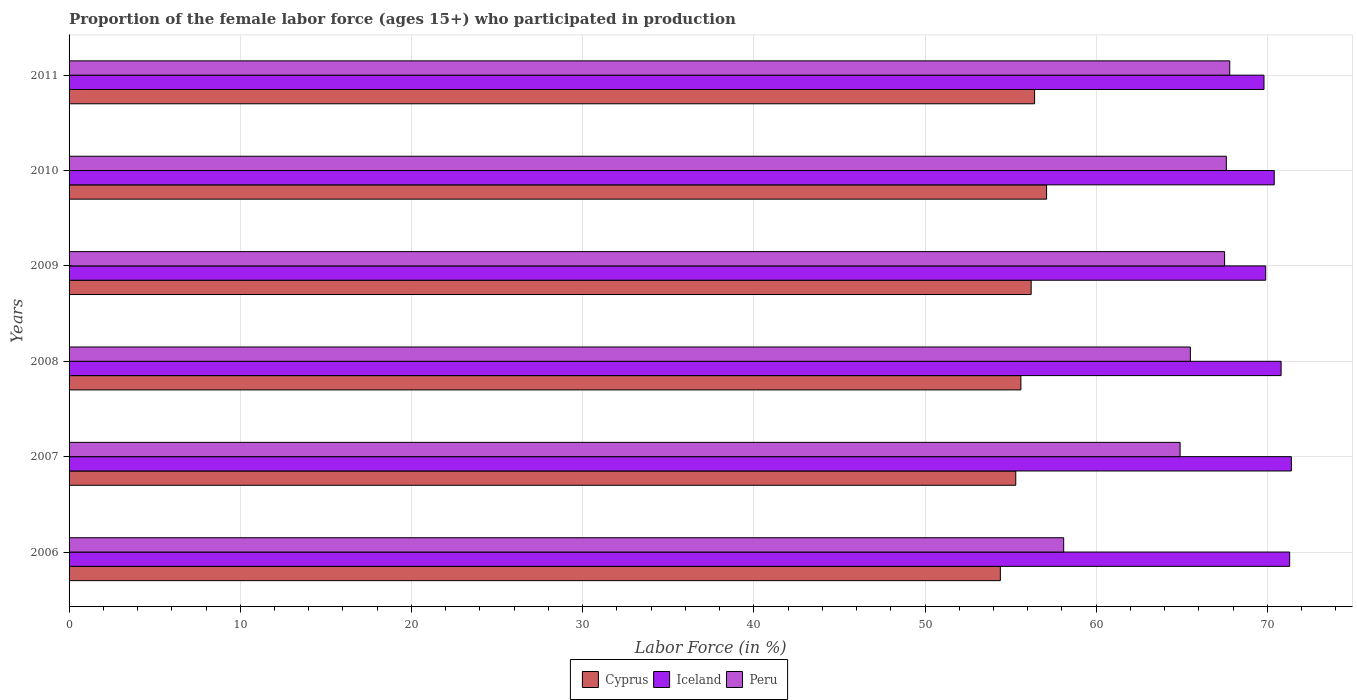How many different coloured bars are there?
Your answer should be compact. 3. How many groups of bars are there?
Provide a succinct answer. 6. Are the number of bars per tick equal to the number of legend labels?
Make the answer very short. Yes. How many bars are there on the 6th tick from the top?
Keep it short and to the point. 3. What is the label of the 4th group of bars from the top?
Provide a short and direct response. 2008. What is the proportion of the female labor force who participated in production in Iceland in 2010?
Offer a terse response. 70.4. Across all years, what is the maximum proportion of the female labor force who participated in production in Iceland?
Keep it short and to the point. 71.4. Across all years, what is the minimum proportion of the female labor force who participated in production in Peru?
Provide a short and direct response. 58.1. In which year was the proportion of the female labor force who participated in production in Iceland maximum?
Offer a terse response. 2007. What is the total proportion of the female labor force who participated in production in Iceland in the graph?
Offer a very short reply. 423.6. What is the difference between the proportion of the female labor force who participated in production in Peru in 2009 and that in 2011?
Offer a terse response. -0.3. What is the difference between the proportion of the female labor force who participated in production in Cyprus in 2010 and the proportion of the female labor force who participated in production in Peru in 2011?
Offer a terse response. -10.7. What is the average proportion of the female labor force who participated in production in Cyprus per year?
Offer a terse response. 55.83. In the year 2006, what is the difference between the proportion of the female labor force who participated in production in Iceland and proportion of the female labor force who participated in production in Peru?
Offer a terse response. 13.2. In how many years, is the proportion of the female labor force who participated in production in Cyprus greater than 48 %?
Your answer should be compact. 6. What is the ratio of the proportion of the female labor force who participated in production in Iceland in 2006 to that in 2009?
Your answer should be very brief. 1.02. What is the difference between the highest and the second highest proportion of the female labor force who participated in production in Cyprus?
Ensure brevity in your answer.  0.7. What is the difference between the highest and the lowest proportion of the female labor force who participated in production in Peru?
Keep it short and to the point. 9.7. In how many years, is the proportion of the female labor force who participated in production in Peru greater than the average proportion of the female labor force who participated in production in Peru taken over all years?
Your answer should be compact. 4. How many bars are there?
Make the answer very short. 18. Are all the bars in the graph horizontal?
Provide a succinct answer. Yes. What is the title of the graph?
Provide a succinct answer. Proportion of the female labor force (ages 15+) who participated in production. Does "Chile" appear as one of the legend labels in the graph?
Offer a terse response. No. What is the Labor Force (in %) in Cyprus in 2006?
Your answer should be compact. 54.4. What is the Labor Force (in %) in Iceland in 2006?
Provide a succinct answer. 71.3. What is the Labor Force (in %) of Peru in 2006?
Keep it short and to the point. 58.1. What is the Labor Force (in %) of Cyprus in 2007?
Offer a very short reply. 55.3. What is the Labor Force (in %) of Iceland in 2007?
Ensure brevity in your answer.  71.4. What is the Labor Force (in %) in Peru in 2007?
Provide a succinct answer. 64.9. What is the Labor Force (in %) of Cyprus in 2008?
Offer a terse response. 55.6. What is the Labor Force (in %) in Iceland in 2008?
Provide a succinct answer. 70.8. What is the Labor Force (in %) of Peru in 2008?
Provide a succinct answer. 65.5. What is the Labor Force (in %) of Cyprus in 2009?
Your response must be concise. 56.2. What is the Labor Force (in %) of Iceland in 2009?
Provide a short and direct response. 69.9. What is the Labor Force (in %) in Peru in 2009?
Ensure brevity in your answer.  67.5. What is the Labor Force (in %) in Cyprus in 2010?
Offer a terse response. 57.1. What is the Labor Force (in %) of Iceland in 2010?
Make the answer very short. 70.4. What is the Labor Force (in %) of Peru in 2010?
Provide a short and direct response. 67.6. What is the Labor Force (in %) of Cyprus in 2011?
Provide a short and direct response. 56.4. What is the Labor Force (in %) of Iceland in 2011?
Your response must be concise. 69.8. What is the Labor Force (in %) of Peru in 2011?
Ensure brevity in your answer.  67.8. Across all years, what is the maximum Labor Force (in %) of Cyprus?
Make the answer very short. 57.1. Across all years, what is the maximum Labor Force (in %) of Iceland?
Provide a succinct answer. 71.4. Across all years, what is the maximum Labor Force (in %) of Peru?
Offer a very short reply. 67.8. Across all years, what is the minimum Labor Force (in %) of Cyprus?
Your answer should be very brief. 54.4. Across all years, what is the minimum Labor Force (in %) of Iceland?
Give a very brief answer. 69.8. Across all years, what is the minimum Labor Force (in %) in Peru?
Your answer should be compact. 58.1. What is the total Labor Force (in %) in Cyprus in the graph?
Your answer should be very brief. 335. What is the total Labor Force (in %) of Iceland in the graph?
Offer a terse response. 423.6. What is the total Labor Force (in %) in Peru in the graph?
Make the answer very short. 391.4. What is the difference between the Labor Force (in %) of Peru in 2006 and that in 2007?
Provide a succinct answer. -6.8. What is the difference between the Labor Force (in %) in Cyprus in 2006 and that in 2009?
Ensure brevity in your answer.  -1.8. What is the difference between the Labor Force (in %) in Iceland in 2006 and that in 2009?
Make the answer very short. 1.4. What is the difference between the Labor Force (in %) in Peru in 2006 and that in 2009?
Your response must be concise. -9.4. What is the difference between the Labor Force (in %) of Cyprus in 2006 and that in 2010?
Give a very brief answer. -2.7. What is the difference between the Labor Force (in %) in Iceland in 2006 and that in 2010?
Provide a succinct answer. 0.9. What is the difference between the Labor Force (in %) in Iceland in 2007 and that in 2008?
Provide a succinct answer. 0.6. What is the difference between the Labor Force (in %) in Iceland in 2007 and that in 2009?
Give a very brief answer. 1.5. What is the difference between the Labor Force (in %) of Peru in 2007 and that in 2009?
Provide a short and direct response. -2.6. What is the difference between the Labor Force (in %) in Peru in 2007 and that in 2010?
Your response must be concise. -2.7. What is the difference between the Labor Force (in %) of Cyprus in 2007 and that in 2011?
Offer a terse response. -1.1. What is the difference between the Labor Force (in %) in Iceland in 2007 and that in 2011?
Keep it short and to the point. 1.6. What is the difference between the Labor Force (in %) of Peru in 2007 and that in 2011?
Your answer should be compact. -2.9. What is the difference between the Labor Force (in %) in Iceland in 2008 and that in 2009?
Make the answer very short. 0.9. What is the difference between the Labor Force (in %) in Peru in 2008 and that in 2009?
Provide a short and direct response. -2. What is the difference between the Labor Force (in %) of Cyprus in 2008 and that in 2010?
Provide a succinct answer. -1.5. What is the difference between the Labor Force (in %) in Peru in 2008 and that in 2010?
Make the answer very short. -2.1. What is the difference between the Labor Force (in %) in Iceland in 2008 and that in 2011?
Provide a succinct answer. 1. What is the difference between the Labor Force (in %) of Peru in 2009 and that in 2010?
Your answer should be very brief. -0.1. What is the difference between the Labor Force (in %) of Cyprus in 2010 and that in 2011?
Keep it short and to the point. 0.7. What is the difference between the Labor Force (in %) of Iceland in 2010 and that in 2011?
Make the answer very short. 0.6. What is the difference between the Labor Force (in %) in Peru in 2010 and that in 2011?
Offer a very short reply. -0.2. What is the difference between the Labor Force (in %) in Cyprus in 2006 and the Labor Force (in %) in Iceland in 2007?
Make the answer very short. -17. What is the difference between the Labor Force (in %) of Iceland in 2006 and the Labor Force (in %) of Peru in 2007?
Provide a succinct answer. 6.4. What is the difference between the Labor Force (in %) of Cyprus in 2006 and the Labor Force (in %) of Iceland in 2008?
Your answer should be very brief. -16.4. What is the difference between the Labor Force (in %) of Cyprus in 2006 and the Labor Force (in %) of Iceland in 2009?
Ensure brevity in your answer.  -15.5. What is the difference between the Labor Force (in %) in Iceland in 2006 and the Labor Force (in %) in Peru in 2009?
Offer a terse response. 3.8. What is the difference between the Labor Force (in %) of Cyprus in 2006 and the Labor Force (in %) of Iceland in 2010?
Offer a terse response. -16. What is the difference between the Labor Force (in %) of Cyprus in 2006 and the Labor Force (in %) of Peru in 2010?
Your answer should be very brief. -13.2. What is the difference between the Labor Force (in %) in Iceland in 2006 and the Labor Force (in %) in Peru in 2010?
Keep it short and to the point. 3.7. What is the difference between the Labor Force (in %) of Cyprus in 2006 and the Labor Force (in %) of Iceland in 2011?
Provide a succinct answer. -15.4. What is the difference between the Labor Force (in %) in Iceland in 2006 and the Labor Force (in %) in Peru in 2011?
Ensure brevity in your answer.  3.5. What is the difference between the Labor Force (in %) in Cyprus in 2007 and the Labor Force (in %) in Iceland in 2008?
Your answer should be compact. -15.5. What is the difference between the Labor Force (in %) in Cyprus in 2007 and the Labor Force (in %) in Peru in 2008?
Give a very brief answer. -10.2. What is the difference between the Labor Force (in %) in Iceland in 2007 and the Labor Force (in %) in Peru in 2008?
Your response must be concise. 5.9. What is the difference between the Labor Force (in %) in Cyprus in 2007 and the Labor Force (in %) in Iceland in 2009?
Provide a succinct answer. -14.6. What is the difference between the Labor Force (in %) in Iceland in 2007 and the Labor Force (in %) in Peru in 2009?
Your response must be concise. 3.9. What is the difference between the Labor Force (in %) of Cyprus in 2007 and the Labor Force (in %) of Iceland in 2010?
Make the answer very short. -15.1. What is the difference between the Labor Force (in %) of Iceland in 2007 and the Labor Force (in %) of Peru in 2010?
Offer a terse response. 3.8. What is the difference between the Labor Force (in %) in Cyprus in 2007 and the Labor Force (in %) in Iceland in 2011?
Keep it short and to the point. -14.5. What is the difference between the Labor Force (in %) of Cyprus in 2008 and the Labor Force (in %) of Iceland in 2009?
Keep it short and to the point. -14.3. What is the difference between the Labor Force (in %) of Cyprus in 2008 and the Labor Force (in %) of Iceland in 2010?
Provide a succinct answer. -14.8. What is the difference between the Labor Force (in %) in Cyprus in 2008 and the Labor Force (in %) in Peru in 2010?
Provide a succinct answer. -12. What is the difference between the Labor Force (in %) of Iceland in 2008 and the Labor Force (in %) of Peru in 2010?
Your answer should be very brief. 3.2. What is the difference between the Labor Force (in %) of Cyprus in 2009 and the Labor Force (in %) of Iceland in 2010?
Provide a short and direct response. -14.2. What is the difference between the Labor Force (in %) in Iceland in 2009 and the Labor Force (in %) in Peru in 2010?
Ensure brevity in your answer.  2.3. What is the difference between the Labor Force (in %) in Cyprus in 2009 and the Labor Force (in %) in Iceland in 2011?
Offer a terse response. -13.6. What is the difference between the Labor Force (in %) of Iceland in 2009 and the Labor Force (in %) of Peru in 2011?
Your answer should be compact. 2.1. What is the difference between the Labor Force (in %) in Cyprus in 2010 and the Labor Force (in %) in Iceland in 2011?
Your answer should be compact. -12.7. What is the difference between the Labor Force (in %) in Cyprus in 2010 and the Labor Force (in %) in Peru in 2011?
Offer a terse response. -10.7. What is the difference between the Labor Force (in %) of Iceland in 2010 and the Labor Force (in %) of Peru in 2011?
Ensure brevity in your answer.  2.6. What is the average Labor Force (in %) of Cyprus per year?
Ensure brevity in your answer.  55.83. What is the average Labor Force (in %) in Iceland per year?
Make the answer very short. 70.6. What is the average Labor Force (in %) in Peru per year?
Provide a succinct answer. 65.23. In the year 2006, what is the difference between the Labor Force (in %) in Cyprus and Labor Force (in %) in Iceland?
Your answer should be very brief. -16.9. In the year 2006, what is the difference between the Labor Force (in %) of Cyprus and Labor Force (in %) of Peru?
Ensure brevity in your answer.  -3.7. In the year 2007, what is the difference between the Labor Force (in %) of Cyprus and Labor Force (in %) of Iceland?
Make the answer very short. -16.1. In the year 2007, what is the difference between the Labor Force (in %) in Iceland and Labor Force (in %) in Peru?
Make the answer very short. 6.5. In the year 2008, what is the difference between the Labor Force (in %) in Cyprus and Labor Force (in %) in Iceland?
Offer a very short reply. -15.2. In the year 2008, what is the difference between the Labor Force (in %) in Cyprus and Labor Force (in %) in Peru?
Keep it short and to the point. -9.9. In the year 2008, what is the difference between the Labor Force (in %) of Iceland and Labor Force (in %) of Peru?
Offer a terse response. 5.3. In the year 2009, what is the difference between the Labor Force (in %) of Cyprus and Labor Force (in %) of Iceland?
Offer a terse response. -13.7. In the year 2010, what is the difference between the Labor Force (in %) in Cyprus and Labor Force (in %) in Peru?
Give a very brief answer. -10.5. In the year 2010, what is the difference between the Labor Force (in %) of Iceland and Labor Force (in %) of Peru?
Offer a very short reply. 2.8. In the year 2011, what is the difference between the Labor Force (in %) of Iceland and Labor Force (in %) of Peru?
Provide a succinct answer. 2. What is the ratio of the Labor Force (in %) in Cyprus in 2006 to that in 2007?
Ensure brevity in your answer.  0.98. What is the ratio of the Labor Force (in %) in Peru in 2006 to that in 2007?
Offer a terse response. 0.9. What is the ratio of the Labor Force (in %) in Cyprus in 2006 to that in 2008?
Make the answer very short. 0.98. What is the ratio of the Labor Force (in %) in Iceland in 2006 to that in 2008?
Keep it short and to the point. 1.01. What is the ratio of the Labor Force (in %) in Peru in 2006 to that in 2008?
Your answer should be very brief. 0.89. What is the ratio of the Labor Force (in %) of Iceland in 2006 to that in 2009?
Keep it short and to the point. 1.02. What is the ratio of the Labor Force (in %) of Peru in 2006 to that in 2009?
Give a very brief answer. 0.86. What is the ratio of the Labor Force (in %) of Cyprus in 2006 to that in 2010?
Your response must be concise. 0.95. What is the ratio of the Labor Force (in %) in Iceland in 2006 to that in 2010?
Offer a terse response. 1.01. What is the ratio of the Labor Force (in %) in Peru in 2006 to that in 2010?
Ensure brevity in your answer.  0.86. What is the ratio of the Labor Force (in %) in Cyprus in 2006 to that in 2011?
Provide a succinct answer. 0.96. What is the ratio of the Labor Force (in %) in Iceland in 2006 to that in 2011?
Offer a very short reply. 1.02. What is the ratio of the Labor Force (in %) in Peru in 2006 to that in 2011?
Provide a short and direct response. 0.86. What is the ratio of the Labor Force (in %) of Iceland in 2007 to that in 2008?
Keep it short and to the point. 1.01. What is the ratio of the Labor Force (in %) of Peru in 2007 to that in 2008?
Give a very brief answer. 0.99. What is the ratio of the Labor Force (in %) of Iceland in 2007 to that in 2009?
Make the answer very short. 1.02. What is the ratio of the Labor Force (in %) in Peru in 2007 to that in 2009?
Provide a succinct answer. 0.96. What is the ratio of the Labor Force (in %) of Cyprus in 2007 to that in 2010?
Your answer should be very brief. 0.97. What is the ratio of the Labor Force (in %) in Iceland in 2007 to that in 2010?
Your response must be concise. 1.01. What is the ratio of the Labor Force (in %) of Peru in 2007 to that in 2010?
Offer a terse response. 0.96. What is the ratio of the Labor Force (in %) of Cyprus in 2007 to that in 2011?
Provide a succinct answer. 0.98. What is the ratio of the Labor Force (in %) in Iceland in 2007 to that in 2011?
Offer a terse response. 1.02. What is the ratio of the Labor Force (in %) in Peru in 2007 to that in 2011?
Provide a succinct answer. 0.96. What is the ratio of the Labor Force (in %) of Cyprus in 2008 to that in 2009?
Your response must be concise. 0.99. What is the ratio of the Labor Force (in %) of Iceland in 2008 to that in 2009?
Provide a succinct answer. 1.01. What is the ratio of the Labor Force (in %) of Peru in 2008 to that in 2009?
Your response must be concise. 0.97. What is the ratio of the Labor Force (in %) in Cyprus in 2008 to that in 2010?
Make the answer very short. 0.97. What is the ratio of the Labor Force (in %) in Peru in 2008 to that in 2010?
Offer a very short reply. 0.97. What is the ratio of the Labor Force (in %) of Cyprus in 2008 to that in 2011?
Provide a succinct answer. 0.99. What is the ratio of the Labor Force (in %) in Iceland in 2008 to that in 2011?
Make the answer very short. 1.01. What is the ratio of the Labor Force (in %) in Peru in 2008 to that in 2011?
Make the answer very short. 0.97. What is the ratio of the Labor Force (in %) in Cyprus in 2009 to that in 2010?
Your answer should be very brief. 0.98. What is the ratio of the Labor Force (in %) of Iceland in 2009 to that in 2010?
Your answer should be very brief. 0.99. What is the ratio of the Labor Force (in %) of Peru in 2009 to that in 2010?
Your answer should be very brief. 1. What is the ratio of the Labor Force (in %) of Cyprus in 2009 to that in 2011?
Your answer should be compact. 1. What is the ratio of the Labor Force (in %) in Cyprus in 2010 to that in 2011?
Make the answer very short. 1.01. What is the ratio of the Labor Force (in %) in Iceland in 2010 to that in 2011?
Ensure brevity in your answer.  1.01. What is the difference between the highest and the second highest Labor Force (in %) in Iceland?
Offer a very short reply. 0.1. What is the difference between the highest and the second highest Labor Force (in %) in Peru?
Offer a terse response. 0.2. What is the difference between the highest and the lowest Labor Force (in %) in Cyprus?
Give a very brief answer. 2.7. What is the difference between the highest and the lowest Labor Force (in %) in Peru?
Provide a succinct answer. 9.7. 